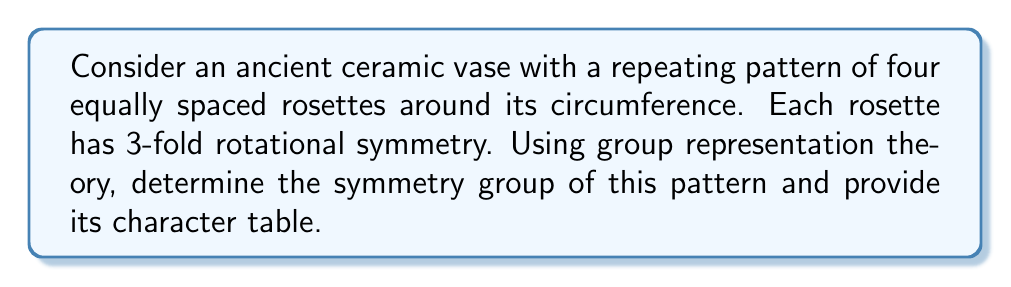Help me with this question. Let's approach this step-by-step:

1) First, we need to identify the symmetries of the pattern:
   - Rotations by 90°, 180°, and 270° around the vase's central axis (C4 symmetry)
   - Reflections across 4 vertical planes
   - Each rosette has 3-fold rotational symmetry (C3 symmetry)

2) The overall symmetry group is a combination of C4 and C3, which forms the direct product group C4 × C3.

3) The order of this group is |C4 × C3| = |C4| × |C3| = 4 × 3 = 12.

4) To construct the character table, we need to identify the conjugacy classes:
   - e: identity
   - c4, c4^3: 90° and 270° rotations
   - c4^2: 180° rotation
   - c3, c3^2: 120° and 240° rotations of rosettes
   - c4c3, c4c3^2, c4^3c3, c4^3c3^2: combinations of C4 and C3 rotations

5) The irreducible representations are:
   - Four 1-dimensional representations from C4: A, B, E1, E2
   - Three 1-dimensional representations from C3: 1, ω, ω^2

6) The character table for C4 × C3 is the Kronecker product of the character tables of C4 and C3:

   $$\begin{array}{c|cccccc}
      C4 \times C3 & e & c4,c4^3 & c4^2 & c3,c3^2 & c4c3,c4c3^2 & c4^3c3,c4^3c3^2 \\
      \hline
      A \otimes 1 & 1 & 1 & 1 & 1 & 1 & 1 \\
      A \otimes \omega & 1 & 1 & 1 & \omega & \omega & \omega \\
      A \otimes \omega^2 & 1 & 1 & 1 & \omega^2 & \omega^2 & \omega^2 \\
      B \otimes 1 & 1 & -1 & 1 & 1 & -1 & -1 \\
      B \otimes \omega & 1 & -1 & 1 & \omega & -\omega & -\omega \\
      B \otimes \omega^2 & 1 & -1 & 1 & \omega^2 & -\omega^2 & -\omega^2 \\
      E1 \otimes 1 & 1 & i & -1 & 1 & i & -i \\
      E1 \otimes \omega & 1 & i & -1 & \omega & i\omega & -i\omega \\
      E1 \otimes \omega^2 & 1 & i & -1 & \omega^2 & i\omega^2 & -i\omega^2 \\
      E2 \otimes 1 & 1 & -i & -1 & 1 & -i & i \\
      E2 \otimes \omega & 1 & -i & -1 & \omega & -i\omega & i\omega \\
      E2 \otimes \omega^2 & 1 & -i & -1 & \omega^2 & -i\omega^2 & i\omega^2
   \end{array}$$

   where $\omega = e^{2\pi i/3} = -\frac{1}{2} + i\frac{\sqrt{3}}{2}$
Answer: C4 × C3 